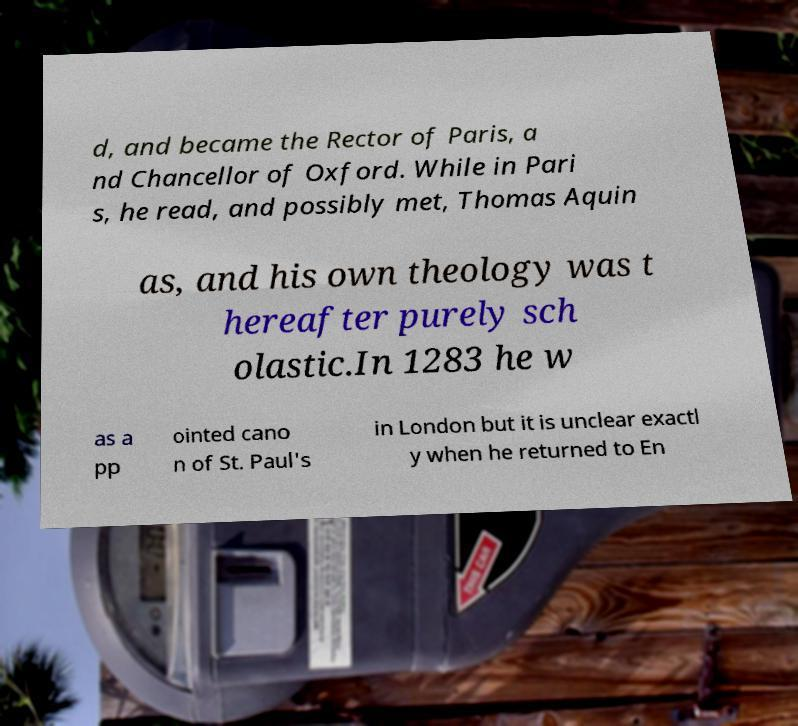Could you extract and type out the text from this image? d, and became the Rector of Paris, a nd Chancellor of Oxford. While in Pari s, he read, and possibly met, Thomas Aquin as, and his own theology was t hereafter purely sch olastic.In 1283 he w as a pp ointed cano n of St. Paul's in London but it is unclear exactl y when he returned to En 